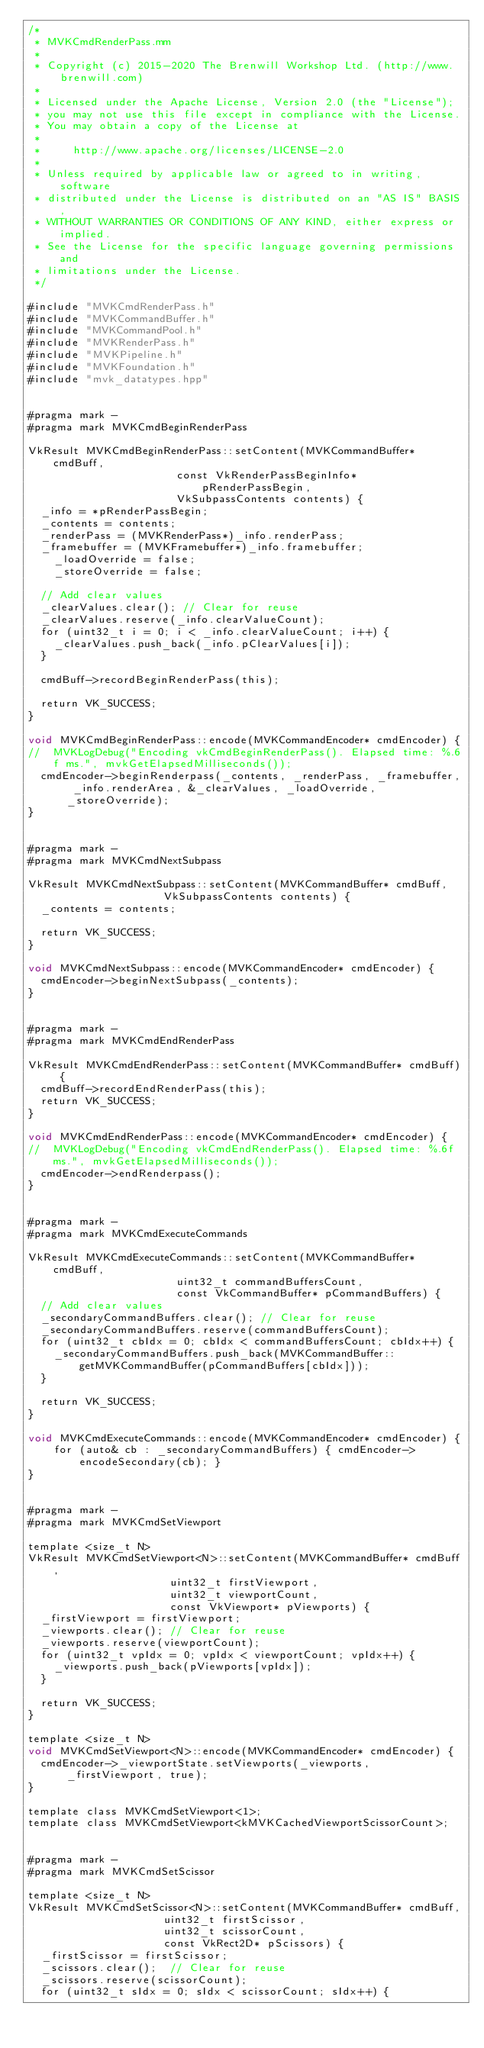Convert code to text. <code><loc_0><loc_0><loc_500><loc_500><_ObjectiveC_>/*
 * MVKCmdRenderPass.mm
 *
 * Copyright (c) 2015-2020 The Brenwill Workshop Ltd. (http://www.brenwill.com)
 *
 * Licensed under the Apache License, Version 2.0 (the "License");
 * you may not use this file except in compliance with the License.
 * You may obtain a copy of the License at
 * 
 *     http://www.apache.org/licenses/LICENSE-2.0
 * 
 * Unless required by applicable law or agreed to in writing, software
 * distributed under the License is distributed on an "AS IS" BASIS,
 * WITHOUT WARRANTIES OR CONDITIONS OF ANY KIND, either express or implied.
 * See the License for the specific language governing permissions and
 * limitations under the License.
 */

#include "MVKCmdRenderPass.h"
#include "MVKCommandBuffer.h"
#include "MVKCommandPool.h"
#include "MVKRenderPass.h"
#include "MVKPipeline.h"
#include "MVKFoundation.h"
#include "mvk_datatypes.hpp"


#pragma mark -
#pragma mark MVKCmdBeginRenderPass

VkResult MVKCmdBeginRenderPass::setContent(MVKCommandBuffer* cmdBuff,
										   const VkRenderPassBeginInfo* pRenderPassBegin,
										   VkSubpassContents contents) {
	_info = *pRenderPassBegin;
	_contents = contents;
	_renderPass = (MVKRenderPass*)_info.renderPass;
	_framebuffer = (MVKFramebuffer*)_info.framebuffer;
    _loadOverride = false;
    _storeOverride = false;

	// Add clear values
	_clearValues.clear();	// Clear for reuse
	_clearValues.reserve(_info.clearValueCount);
	for (uint32_t i = 0; i < _info.clearValueCount; i++) {
		_clearValues.push_back(_info.pClearValues[i]);
	}

	cmdBuff->recordBeginRenderPass(this);

	return VK_SUCCESS;
}

void MVKCmdBeginRenderPass::encode(MVKCommandEncoder* cmdEncoder) {
//	MVKLogDebug("Encoding vkCmdBeginRenderPass(). Elapsed time: %.6f ms.", mvkGetElapsedMilliseconds());
	cmdEncoder->beginRenderpass(_contents, _renderPass, _framebuffer, _info.renderArea, &_clearValues, _loadOverride, _storeOverride);
}


#pragma mark -
#pragma mark MVKCmdNextSubpass

VkResult MVKCmdNextSubpass::setContent(MVKCommandBuffer* cmdBuff,
									   VkSubpassContents contents) {
	_contents = contents;

	return VK_SUCCESS;
}

void MVKCmdNextSubpass::encode(MVKCommandEncoder* cmdEncoder) {
	cmdEncoder->beginNextSubpass(_contents);
}


#pragma mark -
#pragma mark MVKCmdEndRenderPass

VkResult MVKCmdEndRenderPass::setContent(MVKCommandBuffer* cmdBuff) {
	cmdBuff->recordEndRenderPass(this);
	return VK_SUCCESS;
}

void MVKCmdEndRenderPass::encode(MVKCommandEncoder* cmdEncoder) {
//	MVKLogDebug("Encoding vkCmdEndRenderPass(). Elapsed time: %.6f ms.", mvkGetElapsedMilliseconds());
	cmdEncoder->endRenderpass();
}


#pragma mark -
#pragma mark MVKCmdExecuteCommands

VkResult MVKCmdExecuteCommands::setContent(MVKCommandBuffer* cmdBuff,
										   uint32_t commandBuffersCount,
										   const VkCommandBuffer* pCommandBuffers) {
	// Add clear values
	_secondaryCommandBuffers.clear();	// Clear for reuse
	_secondaryCommandBuffers.reserve(commandBuffersCount);
	for (uint32_t cbIdx = 0; cbIdx < commandBuffersCount; cbIdx++) {
		_secondaryCommandBuffers.push_back(MVKCommandBuffer::getMVKCommandBuffer(pCommandBuffers[cbIdx]));
	}

	return VK_SUCCESS;
}

void MVKCmdExecuteCommands::encode(MVKCommandEncoder* cmdEncoder) {
    for (auto& cb : _secondaryCommandBuffers) { cmdEncoder->encodeSecondary(cb); }
}


#pragma mark -
#pragma mark MVKCmdSetViewport

template <size_t N>
VkResult MVKCmdSetViewport<N>::setContent(MVKCommandBuffer* cmdBuff,
										  uint32_t firstViewport,
										  uint32_t viewportCount,
										  const VkViewport* pViewports) {
	_firstViewport = firstViewport;
	_viewports.clear();	// Clear for reuse
	_viewports.reserve(viewportCount);
	for (uint32_t vpIdx = 0; vpIdx < viewportCount; vpIdx++) {
		_viewports.push_back(pViewports[vpIdx]);
	}

	return VK_SUCCESS;
}

template <size_t N>
void MVKCmdSetViewport<N>::encode(MVKCommandEncoder* cmdEncoder) {
	cmdEncoder->_viewportState.setViewports(_viewports, _firstViewport, true);
}

template class MVKCmdSetViewport<1>;
template class MVKCmdSetViewport<kMVKCachedViewportScissorCount>;


#pragma mark -
#pragma mark MVKCmdSetScissor

template <size_t N>
VkResult MVKCmdSetScissor<N>::setContent(MVKCommandBuffer* cmdBuff,
										 uint32_t firstScissor,
										 uint32_t scissorCount,
										 const VkRect2D* pScissors) {
	_firstScissor = firstScissor;
	_scissors.clear();	// Clear for reuse
	_scissors.reserve(scissorCount);
	for (uint32_t sIdx = 0; sIdx < scissorCount; sIdx++) {</code> 